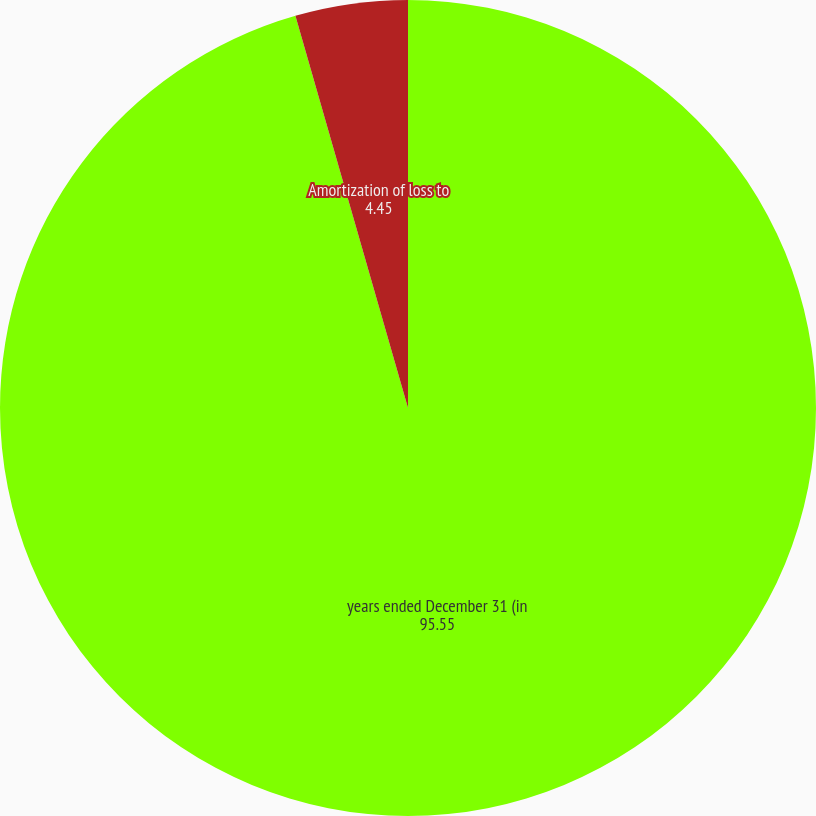Convert chart to OTSL. <chart><loc_0><loc_0><loc_500><loc_500><pie_chart><fcel>years ended December 31 (in<fcel>Amortization of loss to<nl><fcel>95.55%<fcel>4.45%<nl></chart> 